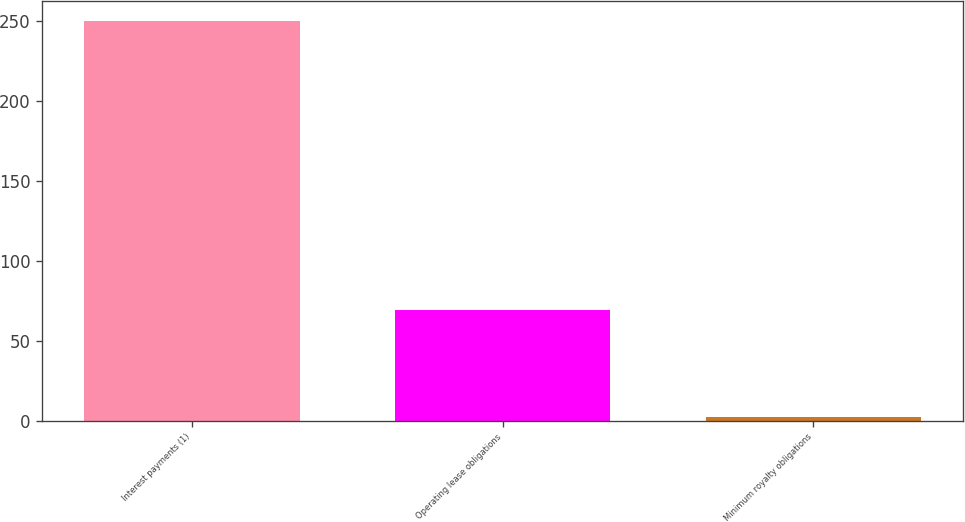Convert chart to OTSL. <chart><loc_0><loc_0><loc_500><loc_500><bar_chart><fcel>Interest payments (1)<fcel>Operating lease obligations<fcel>Minimum royalty obligations<nl><fcel>250<fcel>69<fcel>2<nl></chart> 